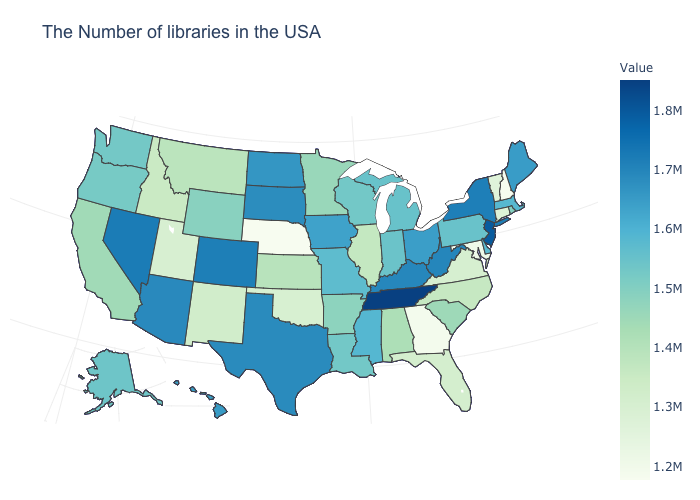Does the map have missing data?
Concise answer only. No. Is the legend a continuous bar?
Write a very short answer. Yes. Does South Dakota have the highest value in the MidWest?
Quick response, please. Yes. Which states hav the highest value in the South?
Be succinct. Tennessee. 